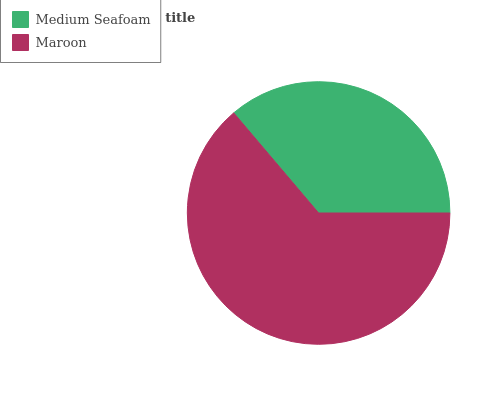Is Medium Seafoam the minimum?
Answer yes or no. Yes. Is Maroon the maximum?
Answer yes or no. Yes. Is Maroon the minimum?
Answer yes or no. No. Is Maroon greater than Medium Seafoam?
Answer yes or no. Yes. Is Medium Seafoam less than Maroon?
Answer yes or no. Yes. Is Medium Seafoam greater than Maroon?
Answer yes or no. No. Is Maroon less than Medium Seafoam?
Answer yes or no. No. Is Maroon the high median?
Answer yes or no. Yes. Is Medium Seafoam the low median?
Answer yes or no. Yes. Is Medium Seafoam the high median?
Answer yes or no. No. Is Maroon the low median?
Answer yes or no. No. 